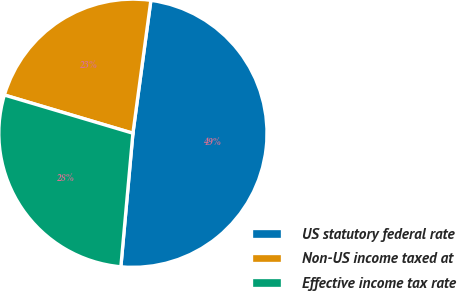Convert chart to OTSL. <chart><loc_0><loc_0><loc_500><loc_500><pie_chart><fcel>US statutory federal rate<fcel>Non-US income taxed at<fcel>Effective income tax rate<nl><fcel>49.3%<fcel>22.54%<fcel>28.17%<nl></chart> 